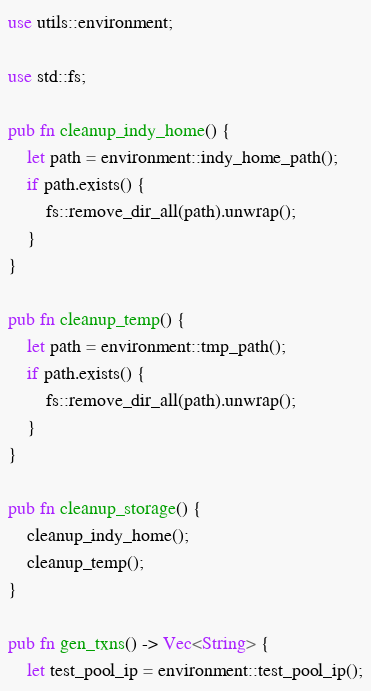<code> <loc_0><loc_0><loc_500><loc_500><_Rust_>use utils::environment;

use std::fs;

pub fn cleanup_indy_home() {
    let path = environment::indy_home_path();
    if path.exists() {
        fs::remove_dir_all(path).unwrap();
    }
}

pub fn cleanup_temp() {
    let path = environment::tmp_path();
    if path.exists() {
        fs::remove_dir_all(path).unwrap();
    }
}

pub fn cleanup_storage() {
    cleanup_indy_home();
    cleanup_temp();
}

pub fn gen_txns() -> Vec<String> {
    let test_pool_ip = environment::test_pool_ip();
</code> 